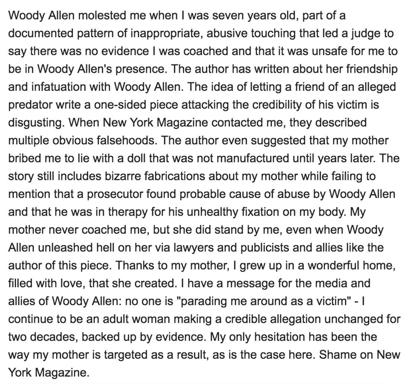What are some of the criticisms leveled against the New York Magazine piece? The criticisms of the New York Magazine article are sharp and multifaceted. The author denounces the article for propagating outright lies, such as the anachronistic bribe of a doll and for crafting strange fabrications about her mother's actions. Critically, the article is also faulted for not acknowledging the significant finding by a prosecutor of probable cause for abuse claims against Woody Allen. 